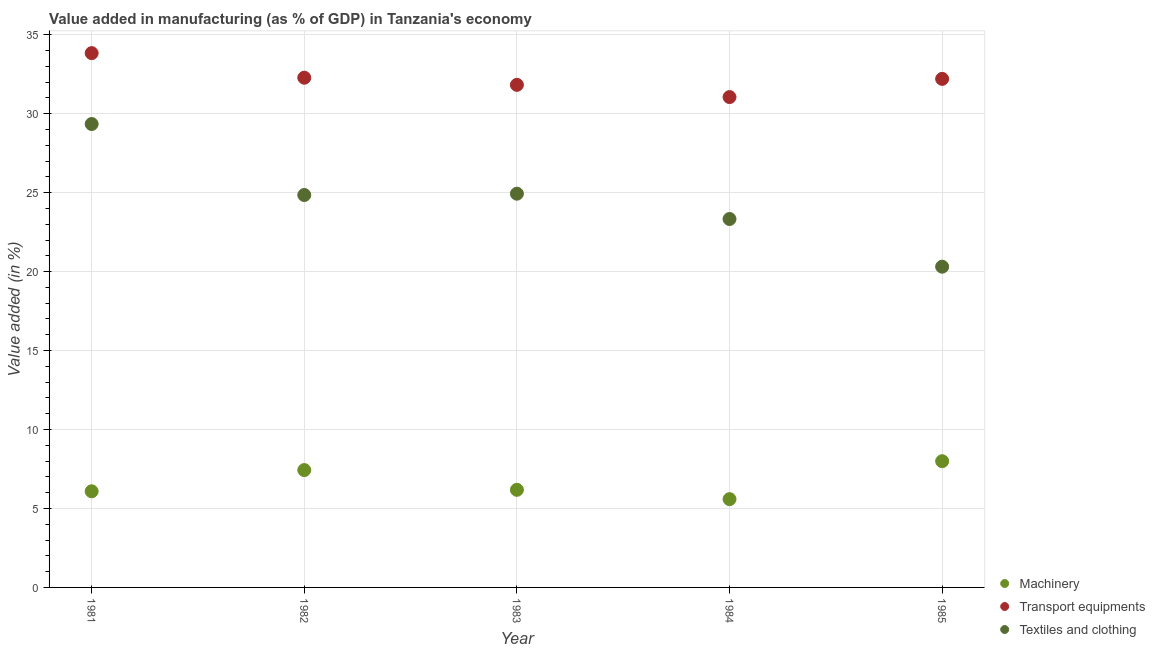How many different coloured dotlines are there?
Offer a terse response. 3. Is the number of dotlines equal to the number of legend labels?
Your answer should be compact. Yes. What is the value added in manufacturing transport equipments in 1982?
Provide a succinct answer. 32.28. Across all years, what is the maximum value added in manufacturing machinery?
Offer a terse response. 7.99. Across all years, what is the minimum value added in manufacturing machinery?
Provide a short and direct response. 5.59. What is the total value added in manufacturing transport equipments in the graph?
Make the answer very short. 161.2. What is the difference between the value added in manufacturing machinery in 1981 and that in 1985?
Provide a short and direct response. -1.91. What is the difference between the value added in manufacturing machinery in 1985 and the value added in manufacturing transport equipments in 1981?
Keep it short and to the point. -25.84. What is the average value added in manufacturing textile and clothing per year?
Make the answer very short. 24.55. In the year 1983, what is the difference between the value added in manufacturing textile and clothing and value added in manufacturing transport equipments?
Ensure brevity in your answer.  -6.89. In how many years, is the value added in manufacturing machinery greater than 4 %?
Ensure brevity in your answer.  5. What is the ratio of the value added in manufacturing transport equipments in 1982 to that in 1984?
Give a very brief answer. 1.04. Is the value added in manufacturing transport equipments in 1984 less than that in 1985?
Your response must be concise. Yes. Is the difference between the value added in manufacturing machinery in 1982 and 1983 greater than the difference between the value added in manufacturing textile and clothing in 1982 and 1983?
Ensure brevity in your answer.  Yes. What is the difference between the highest and the second highest value added in manufacturing textile and clothing?
Provide a short and direct response. 4.41. What is the difference between the highest and the lowest value added in manufacturing transport equipments?
Your answer should be compact. 2.78. In how many years, is the value added in manufacturing textile and clothing greater than the average value added in manufacturing textile and clothing taken over all years?
Keep it short and to the point. 3. Is it the case that in every year, the sum of the value added in manufacturing machinery and value added in manufacturing transport equipments is greater than the value added in manufacturing textile and clothing?
Offer a very short reply. Yes. Does the value added in manufacturing transport equipments monotonically increase over the years?
Make the answer very short. No. How many dotlines are there?
Ensure brevity in your answer.  3. Does the graph contain grids?
Give a very brief answer. Yes. Where does the legend appear in the graph?
Keep it short and to the point. Bottom right. How many legend labels are there?
Your answer should be very brief. 3. How are the legend labels stacked?
Your answer should be very brief. Vertical. What is the title of the graph?
Offer a terse response. Value added in manufacturing (as % of GDP) in Tanzania's economy. Does "Non-communicable diseases" appear as one of the legend labels in the graph?
Make the answer very short. No. What is the label or title of the Y-axis?
Your answer should be very brief. Value added (in %). What is the Value added (in %) of Machinery in 1981?
Your answer should be very brief. 6.09. What is the Value added (in %) of Transport equipments in 1981?
Provide a short and direct response. 33.84. What is the Value added (in %) of Textiles and clothing in 1981?
Provide a succinct answer. 29.35. What is the Value added (in %) of Machinery in 1982?
Make the answer very short. 7.43. What is the Value added (in %) in Transport equipments in 1982?
Provide a succinct answer. 32.28. What is the Value added (in %) of Textiles and clothing in 1982?
Your answer should be very brief. 24.85. What is the Value added (in %) in Machinery in 1983?
Give a very brief answer. 6.18. What is the Value added (in %) of Transport equipments in 1983?
Keep it short and to the point. 31.83. What is the Value added (in %) of Textiles and clothing in 1983?
Keep it short and to the point. 24.93. What is the Value added (in %) in Machinery in 1984?
Ensure brevity in your answer.  5.59. What is the Value added (in %) of Transport equipments in 1984?
Provide a short and direct response. 31.05. What is the Value added (in %) of Textiles and clothing in 1984?
Make the answer very short. 23.33. What is the Value added (in %) in Machinery in 1985?
Your answer should be very brief. 7.99. What is the Value added (in %) in Transport equipments in 1985?
Your response must be concise. 32.21. What is the Value added (in %) in Textiles and clothing in 1985?
Provide a succinct answer. 20.31. Across all years, what is the maximum Value added (in %) of Machinery?
Your response must be concise. 7.99. Across all years, what is the maximum Value added (in %) of Transport equipments?
Your answer should be very brief. 33.84. Across all years, what is the maximum Value added (in %) of Textiles and clothing?
Make the answer very short. 29.35. Across all years, what is the minimum Value added (in %) of Machinery?
Provide a short and direct response. 5.59. Across all years, what is the minimum Value added (in %) of Transport equipments?
Ensure brevity in your answer.  31.05. Across all years, what is the minimum Value added (in %) in Textiles and clothing?
Your answer should be very brief. 20.31. What is the total Value added (in %) of Machinery in the graph?
Your answer should be compact. 33.28. What is the total Value added (in %) of Transport equipments in the graph?
Keep it short and to the point. 161.2. What is the total Value added (in %) in Textiles and clothing in the graph?
Give a very brief answer. 122.77. What is the difference between the Value added (in %) of Machinery in 1981 and that in 1982?
Your response must be concise. -1.34. What is the difference between the Value added (in %) in Transport equipments in 1981 and that in 1982?
Offer a terse response. 1.56. What is the difference between the Value added (in %) in Textiles and clothing in 1981 and that in 1982?
Your answer should be compact. 4.5. What is the difference between the Value added (in %) in Machinery in 1981 and that in 1983?
Offer a very short reply. -0.09. What is the difference between the Value added (in %) of Transport equipments in 1981 and that in 1983?
Ensure brevity in your answer.  2.01. What is the difference between the Value added (in %) of Textiles and clothing in 1981 and that in 1983?
Offer a terse response. 4.41. What is the difference between the Value added (in %) in Machinery in 1981 and that in 1984?
Provide a succinct answer. 0.5. What is the difference between the Value added (in %) of Transport equipments in 1981 and that in 1984?
Your answer should be very brief. 2.78. What is the difference between the Value added (in %) of Textiles and clothing in 1981 and that in 1984?
Offer a very short reply. 6.01. What is the difference between the Value added (in %) of Machinery in 1981 and that in 1985?
Ensure brevity in your answer.  -1.91. What is the difference between the Value added (in %) of Transport equipments in 1981 and that in 1985?
Your answer should be very brief. 1.63. What is the difference between the Value added (in %) in Textiles and clothing in 1981 and that in 1985?
Provide a short and direct response. 9.03. What is the difference between the Value added (in %) of Machinery in 1982 and that in 1983?
Your answer should be compact. 1.25. What is the difference between the Value added (in %) in Transport equipments in 1982 and that in 1983?
Make the answer very short. 0.45. What is the difference between the Value added (in %) of Textiles and clothing in 1982 and that in 1983?
Offer a terse response. -0.08. What is the difference between the Value added (in %) of Machinery in 1982 and that in 1984?
Provide a succinct answer. 1.84. What is the difference between the Value added (in %) of Transport equipments in 1982 and that in 1984?
Give a very brief answer. 1.23. What is the difference between the Value added (in %) in Textiles and clothing in 1982 and that in 1984?
Ensure brevity in your answer.  1.52. What is the difference between the Value added (in %) of Machinery in 1982 and that in 1985?
Your response must be concise. -0.56. What is the difference between the Value added (in %) in Transport equipments in 1982 and that in 1985?
Your answer should be compact. 0.07. What is the difference between the Value added (in %) of Textiles and clothing in 1982 and that in 1985?
Provide a short and direct response. 4.54. What is the difference between the Value added (in %) of Machinery in 1983 and that in 1984?
Your answer should be very brief. 0.59. What is the difference between the Value added (in %) in Transport equipments in 1983 and that in 1984?
Your answer should be compact. 0.77. What is the difference between the Value added (in %) of Textiles and clothing in 1983 and that in 1984?
Your answer should be compact. 1.6. What is the difference between the Value added (in %) of Machinery in 1983 and that in 1985?
Offer a terse response. -1.81. What is the difference between the Value added (in %) of Transport equipments in 1983 and that in 1985?
Provide a succinct answer. -0.38. What is the difference between the Value added (in %) of Textiles and clothing in 1983 and that in 1985?
Offer a very short reply. 4.62. What is the difference between the Value added (in %) of Machinery in 1984 and that in 1985?
Keep it short and to the point. -2.4. What is the difference between the Value added (in %) in Transport equipments in 1984 and that in 1985?
Ensure brevity in your answer.  -1.15. What is the difference between the Value added (in %) in Textiles and clothing in 1984 and that in 1985?
Provide a short and direct response. 3.02. What is the difference between the Value added (in %) in Machinery in 1981 and the Value added (in %) in Transport equipments in 1982?
Your response must be concise. -26.19. What is the difference between the Value added (in %) in Machinery in 1981 and the Value added (in %) in Textiles and clothing in 1982?
Make the answer very short. -18.76. What is the difference between the Value added (in %) of Transport equipments in 1981 and the Value added (in %) of Textiles and clothing in 1982?
Provide a short and direct response. 8.98. What is the difference between the Value added (in %) of Machinery in 1981 and the Value added (in %) of Transport equipments in 1983?
Ensure brevity in your answer.  -25.74. What is the difference between the Value added (in %) in Machinery in 1981 and the Value added (in %) in Textiles and clothing in 1983?
Provide a short and direct response. -18.85. What is the difference between the Value added (in %) of Transport equipments in 1981 and the Value added (in %) of Textiles and clothing in 1983?
Provide a short and direct response. 8.9. What is the difference between the Value added (in %) of Machinery in 1981 and the Value added (in %) of Transport equipments in 1984?
Your response must be concise. -24.97. What is the difference between the Value added (in %) of Machinery in 1981 and the Value added (in %) of Textiles and clothing in 1984?
Your response must be concise. -17.24. What is the difference between the Value added (in %) in Transport equipments in 1981 and the Value added (in %) in Textiles and clothing in 1984?
Provide a short and direct response. 10.5. What is the difference between the Value added (in %) of Machinery in 1981 and the Value added (in %) of Transport equipments in 1985?
Ensure brevity in your answer.  -26.12. What is the difference between the Value added (in %) of Machinery in 1981 and the Value added (in %) of Textiles and clothing in 1985?
Keep it short and to the point. -14.22. What is the difference between the Value added (in %) in Transport equipments in 1981 and the Value added (in %) in Textiles and clothing in 1985?
Offer a very short reply. 13.52. What is the difference between the Value added (in %) of Machinery in 1982 and the Value added (in %) of Transport equipments in 1983?
Make the answer very short. -24.4. What is the difference between the Value added (in %) in Machinery in 1982 and the Value added (in %) in Textiles and clothing in 1983?
Your answer should be compact. -17.5. What is the difference between the Value added (in %) of Transport equipments in 1982 and the Value added (in %) of Textiles and clothing in 1983?
Make the answer very short. 7.34. What is the difference between the Value added (in %) of Machinery in 1982 and the Value added (in %) of Transport equipments in 1984?
Your answer should be compact. -23.62. What is the difference between the Value added (in %) in Machinery in 1982 and the Value added (in %) in Textiles and clothing in 1984?
Keep it short and to the point. -15.9. What is the difference between the Value added (in %) of Transport equipments in 1982 and the Value added (in %) of Textiles and clothing in 1984?
Your answer should be very brief. 8.95. What is the difference between the Value added (in %) in Machinery in 1982 and the Value added (in %) in Transport equipments in 1985?
Make the answer very short. -24.77. What is the difference between the Value added (in %) of Machinery in 1982 and the Value added (in %) of Textiles and clothing in 1985?
Offer a very short reply. -12.88. What is the difference between the Value added (in %) in Transport equipments in 1982 and the Value added (in %) in Textiles and clothing in 1985?
Provide a succinct answer. 11.97. What is the difference between the Value added (in %) in Machinery in 1983 and the Value added (in %) in Transport equipments in 1984?
Offer a very short reply. -24.87. What is the difference between the Value added (in %) of Machinery in 1983 and the Value added (in %) of Textiles and clothing in 1984?
Provide a short and direct response. -17.15. What is the difference between the Value added (in %) of Transport equipments in 1983 and the Value added (in %) of Textiles and clothing in 1984?
Offer a terse response. 8.49. What is the difference between the Value added (in %) of Machinery in 1983 and the Value added (in %) of Transport equipments in 1985?
Ensure brevity in your answer.  -26.02. What is the difference between the Value added (in %) of Machinery in 1983 and the Value added (in %) of Textiles and clothing in 1985?
Your answer should be compact. -14.13. What is the difference between the Value added (in %) of Transport equipments in 1983 and the Value added (in %) of Textiles and clothing in 1985?
Your answer should be compact. 11.52. What is the difference between the Value added (in %) in Machinery in 1984 and the Value added (in %) in Transport equipments in 1985?
Offer a very short reply. -26.61. What is the difference between the Value added (in %) of Machinery in 1984 and the Value added (in %) of Textiles and clothing in 1985?
Your answer should be very brief. -14.72. What is the difference between the Value added (in %) in Transport equipments in 1984 and the Value added (in %) in Textiles and clothing in 1985?
Offer a very short reply. 10.74. What is the average Value added (in %) in Machinery per year?
Offer a very short reply. 6.66. What is the average Value added (in %) of Transport equipments per year?
Your response must be concise. 32.24. What is the average Value added (in %) of Textiles and clothing per year?
Offer a very short reply. 24.55. In the year 1981, what is the difference between the Value added (in %) of Machinery and Value added (in %) of Transport equipments?
Make the answer very short. -27.75. In the year 1981, what is the difference between the Value added (in %) in Machinery and Value added (in %) in Textiles and clothing?
Give a very brief answer. -23.26. In the year 1981, what is the difference between the Value added (in %) of Transport equipments and Value added (in %) of Textiles and clothing?
Ensure brevity in your answer.  4.49. In the year 1982, what is the difference between the Value added (in %) of Machinery and Value added (in %) of Transport equipments?
Give a very brief answer. -24.85. In the year 1982, what is the difference between the Value added (in %) in Machinery and Value added (in %) in Textiles and clothing?
Your response must be concise. -17.42. In the year 1982, what is the difference between the Value added (in %) in Transport equipments and Value added (in %) in Textiles and clothing?
Your answer should be very brief. 7.43. In the year 1983, what is the difference between the Value added (in %) of Machinery and Value added (in %) of Transport equipments?
Your answer should be compact. -25.65. In the year 1983, what is the difference between the Value added (in %) in Machinery and Value added (in %) in Textiles and clothing?
Provide a succinct answer. -18.75. In the year 1983, what is the difference between the Value added (in %) of Transport equipments and Value added (in %) of Textiles and clothing?
Keep it short and to the point. 6.89. In the year 1984, what is the difference between the Value added (in %) in Machinery and Value added (in %) in Transport equipments?
Keep it short and to the point. -25.46. In the year 1984, what is the difference between the Value added (in %) in Machinery and Value added (in %) in Textiles and clothing?
Keep it short and to the point. -17.74. In the year 1984, what is the difference between the Value added (in %) in Transport equipments and Value added (in %) in Textiles and clothing?
Offer a terse response. 7.72. In the year 1985, what is the difference between the Value added (in %) in Machinery and Value added (in %) in Transport equipments?
Give a very brief answer. -24.21. In the year 1985, what is the difference between the Value added (in %) of Machinery and Value added (in %) of Textiles and clothing?
Give a very brief answer. -12.32. In the year 1985, what is the difference between the Value added (in %) in Transport equipments and Value added (in %) in Textiles and clothing?
Your answer should be compact. 11.89. What is the ratio of the Value added (in %) in Machinery in 1981 to that in 1982?
Offer a terse response. 0.82. What is the ratio of the Value added (in %) in Transport equipments in 1981 to that in 1982?
Provide a succinct answer. 1.05. What is the ratio of the Value added (in %) in Textiles and clothing in 1981 to that in 1982?
Your answer should be very brief. 1.18. What is the ratio of the Value added (in %) of Machinery in 1981 to that in 1983?
Give a very brief answer. 0.98. What is the ratio of the Value added (in %) in Transport equipments in 1981 to that in 1983?
Your answer should be very brief. 1.06. What is the ratio of the Value added (in %) of Textiles and clothing in 1981 to that in 1983?
Your answer should be very brief. 1.18. What is the ratio of the Value added (in %) in Machinery in 1981 to that in 1984?
Your answer should be compact. 1.09. What is the ratio of the Value added (in %) in Transport equipments in 1981 to that in 1984?
Give a very brief answer. 1.09. What is the ratio of the Value added (in %) of Textiles and clothing in 1981 to that in 1984?
Provide a short and direct response. 1.26. What is the ratio of the Value added (in %) of Machinery in 1981 to that in 1985?
Offer a very short reply. 0.76. What is the ratio of the Value added (in %) in Transport equipments in 1981 to that in 1985?
Your answer should be very brief. 1.05. What is the ratio of the Value added (in %) of Textiles and clothing in 1981 to that in 1985?
Offer a very short reply. 1.44. What is the ratio of the Value added (in %) in Machinery in 1982 to that in 1983?
Give a very brief answer. 1.2. What is the ratio of the Value added (in %) of Transport equipments in 1982 to that in 1983?
Offer a terse response. 1.01. What is the ratio of the Value added (in %) in Machinery in 1982 to that in 1984?
Offer a terse response. 1.33. What is the ratio of the Value added (in %) in Transport equipments in 1982 to that in 1984?
Keep it short and to the point. 1.04. What is the ratio of the Value added (in %) of Textiles and clothing in 1982 to that in 1984?
Your answer should be very brief. 1.07. What is the ratio of the Value added (in %) in Machinery in 1982 to that in 1985?
Provide a succinct answer. 0.93. What is the ratio of the Value added (in %) in Textiles and clothing in 1982 to that in 1985?
Provide a short and direct response. 1.22. What is the ratio of the Value added (in %) of Machinery in 1983 to that in 1984?
Your answer should be compact. 1.11. What is the ratio of the Value added (in %) of Transport equipments in 1983 to that in 1984?
Provide a succinct answer. 1.02. What is the ratio of the Value added (in %) of Textiles and clothing in 1983 to that in 1984?
Your answer should be very brief. 1.07. What is the ratio of the Value added (in %) in Machinery in 1983 to that in 1985?
Keep it short and to the point. 0.77. What is the ratio of the Value added (in %) of Textiles and clothing in 1983 to that in 1985?
Offer a terse response. 1.23. What is the ratio of the Value added (in %) of Machinery in 1984 to that in 1985?
Your response must be concise. 0.7. What is the ratio of the Value added (in %) of Transport equipments in 1984 to that in 1985?
Your answer should be compact. 0.96. What is the ratio of the Value added (in %) of Textiles and clothing in 1984 to that in 1985?
Offer a very short reply. 1.15. What is the difference between the highest and the second highest Value added (in %) in Machinery?
Make the answer very short. 0.56. What is the difference between the highest and the second highest Value added (in %) of Transport equipments?
Offer a very short reply. 1.56. What is the difference between the highest and the second highest Value added (in %) in Textiles and clothing?
Make the answer very short. 4.41. What is the difference between the highest and the lowest Value added (in %) of Machinery?
Provide a short and direct response. 2.4. What is the difference between the highest and the lowest Value added (in %) in Transport equipments?
Your answer should be very brief. 2.78. What is the difference between the highest and the lowest Value added (in %) in Textiles and clothing?
Your answer should be compact. 9.03. 